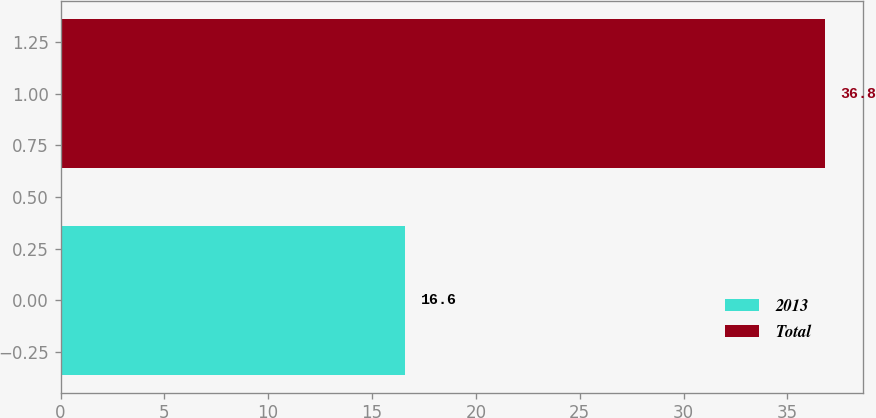<chart> <loc_0><loc_0><loc_500><loc_500><bar_chart><fcel>2013<fcel>Total<nl><fcel>16.6<fcel>36.8<nl></chart> 